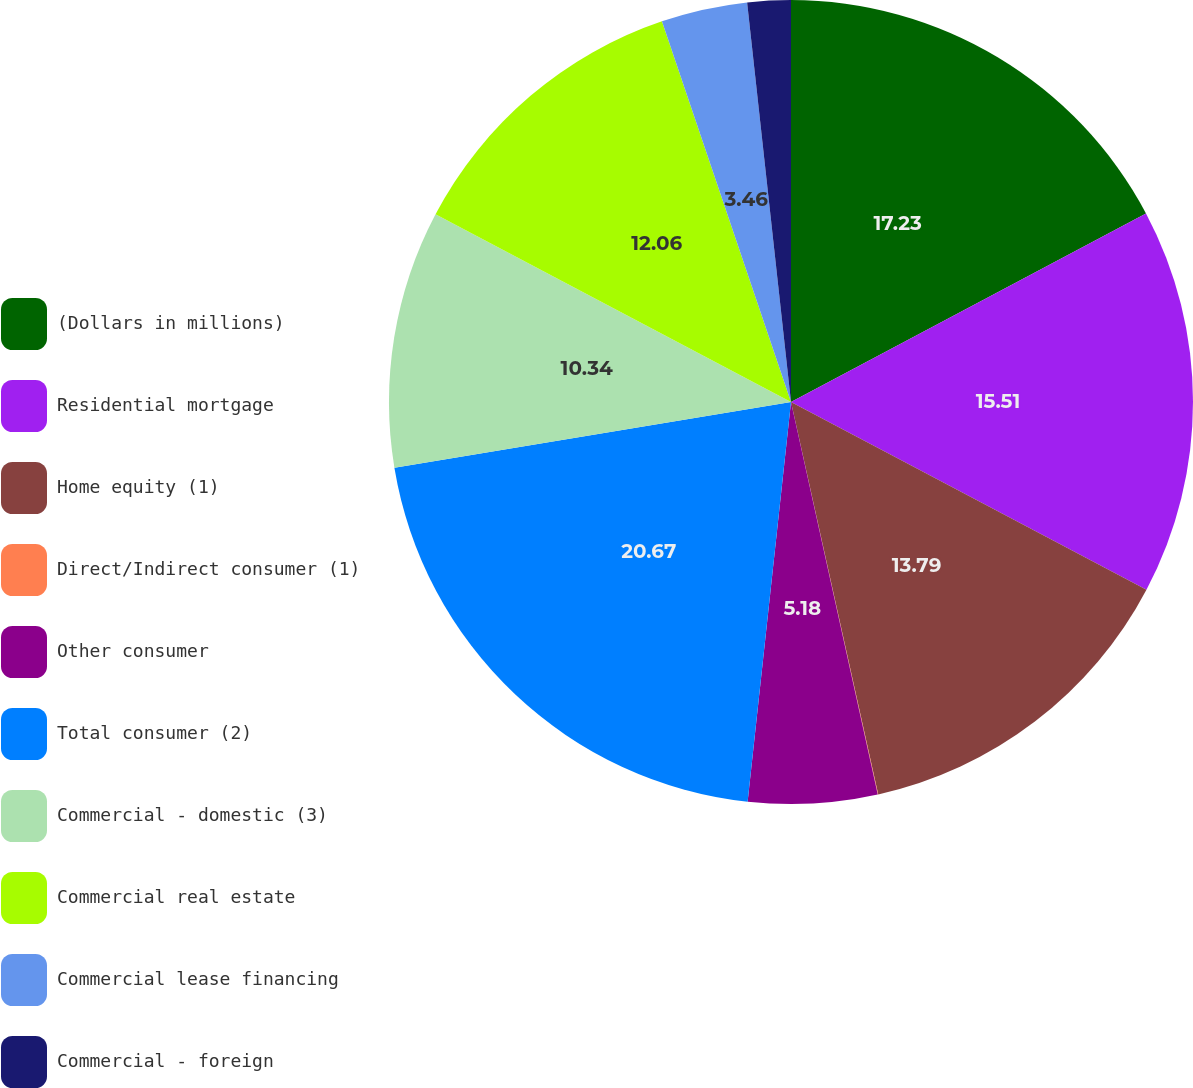Convert chart to OTSL. <chart><loc_0><loc_0><loc_500><loc_500><pie_chart><fcel>(Dollars in millions)<fcel>Residential mortgage<fcel>Home equity (1)<fcel>Direct/Indirect consumer (1)<fcel>Other consumer<fcel>Total consumer (2)<fcel>Commercial - domestic (3)<fcel>Commercial real estate<fcel>Commercial lease financing<fcel>Commercial - foreign<nl><fcel>17.22%<fcel>15.5%<fcel>13.78%<fcel>0.02%<fcel>5.18%<fcel>20.66%<fcel>10.34%<fcel>12.06%<fcel>3.46%<fcel>1.74%<nl></chart> 